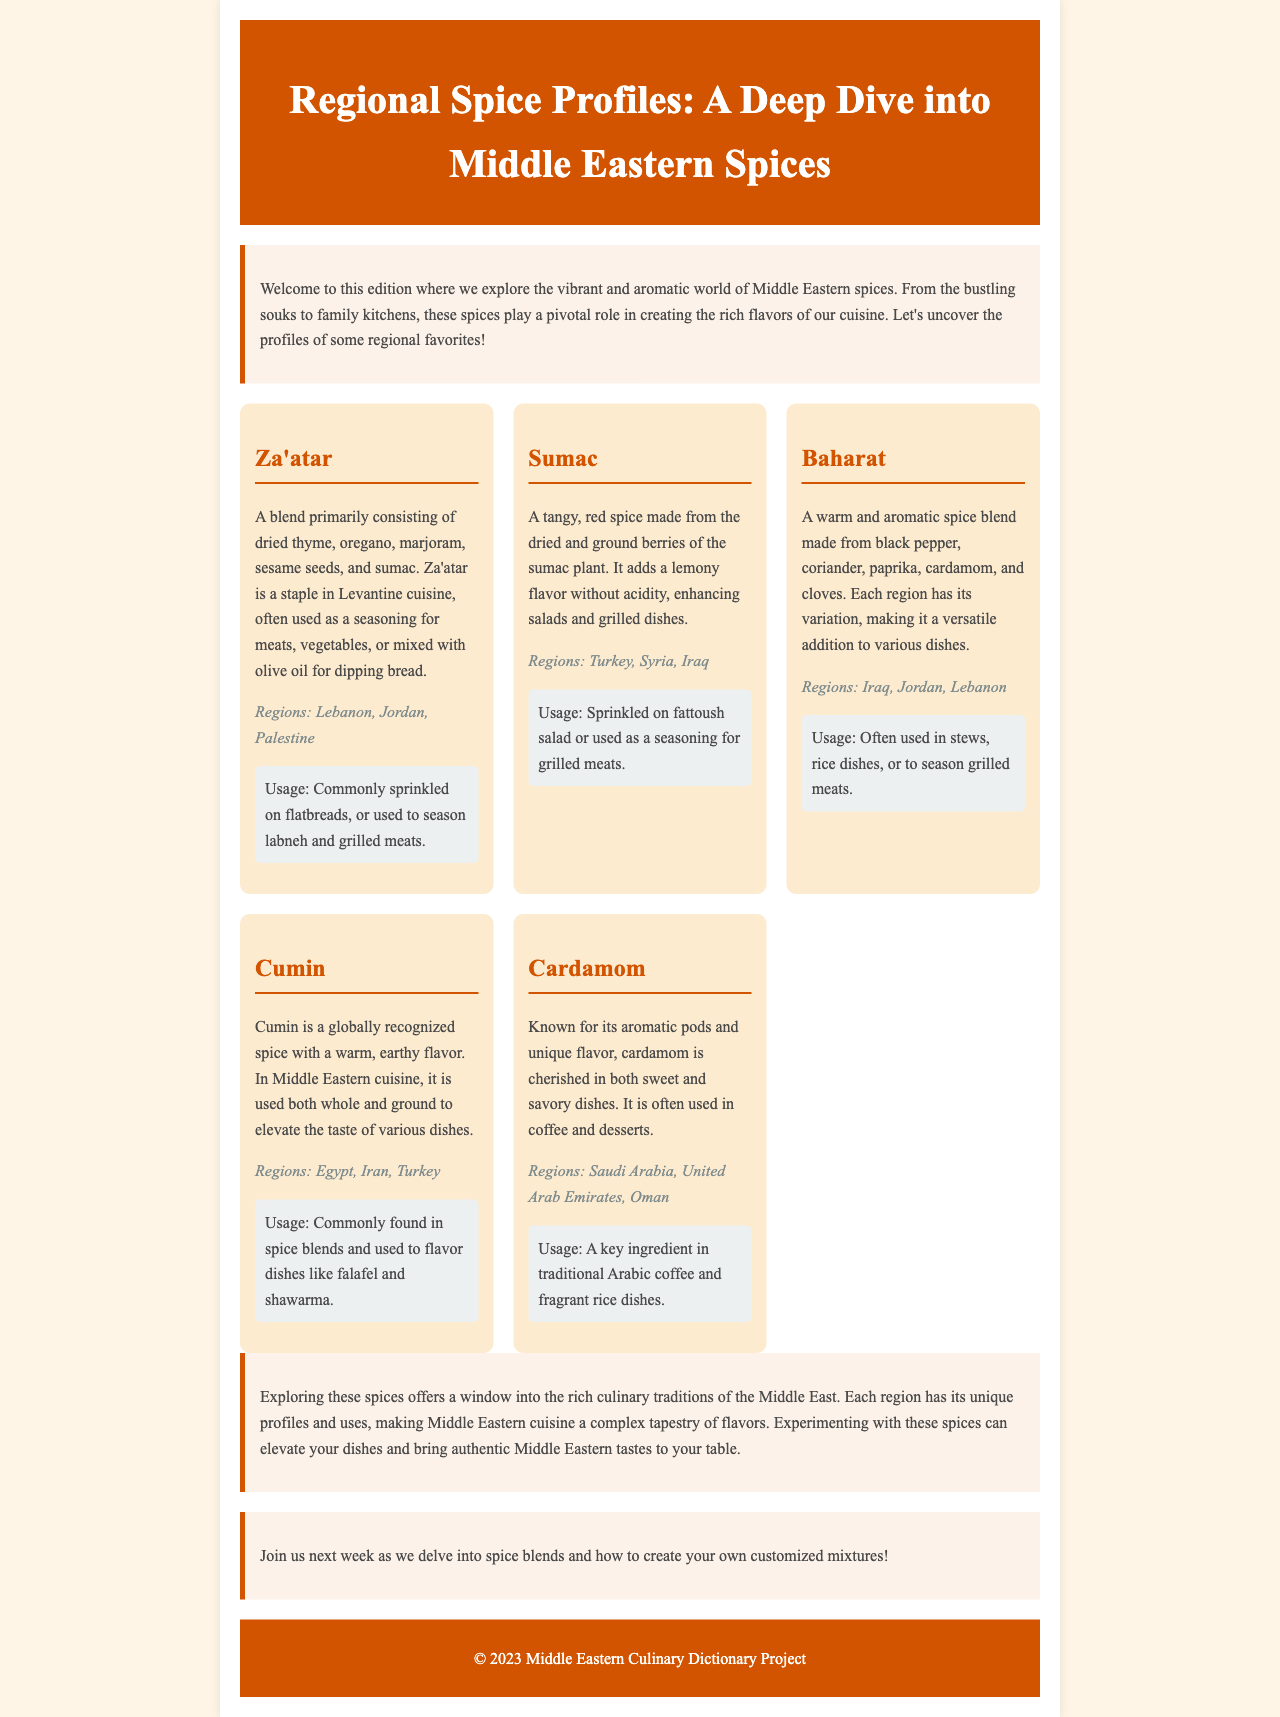What is the main topic of the newsletter? The main topic of the newsletter is about exploring Middle Eastern spices and their profiles.
Answer: Middle Eastern spices How many spices are detailed in the document? The document outlines five specific spices in the spice grid section.
Answer: Five Which spice is used in traditional Arabic coffee? The spice specifically mentioned for traditional Arabic coffee is cardamom.
Answer: Cardamom What regions are associated with Za'atar? Za'atar is associated with Lebanon, Jordan, and Palestine.
Answer: Lebanon, Jordan, Palestine What is the primary flavor profile of Sumac? Sumac adds a tangy and lemony flavor without acidity.
Answer: Tangy, lemony Which spice blend is mentioned as versatile and varies by region? The versatile spice blend mentioned is Baharat.
Answer: Baharat What does the conclusion suggest about experimenting with these spices? The conclusion suggests that experimenting with these spices can elevate your dishes and bring authentic flavors.
Answer: Elevate your dishes What is the call to action for the next newsletter? The call to action invites readers to join next week for a discussion on creating customized spice blends.
Answer: Customized spice blends 